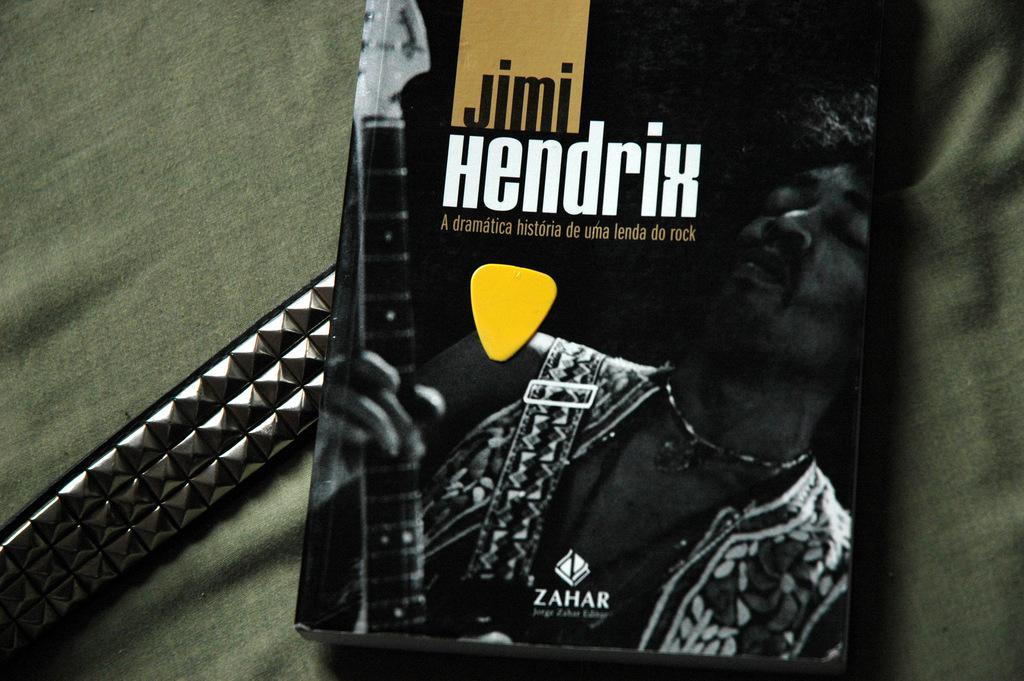<image>
Describe the image concisely. Black Jimi Hendrix book on top of a silver belt. 